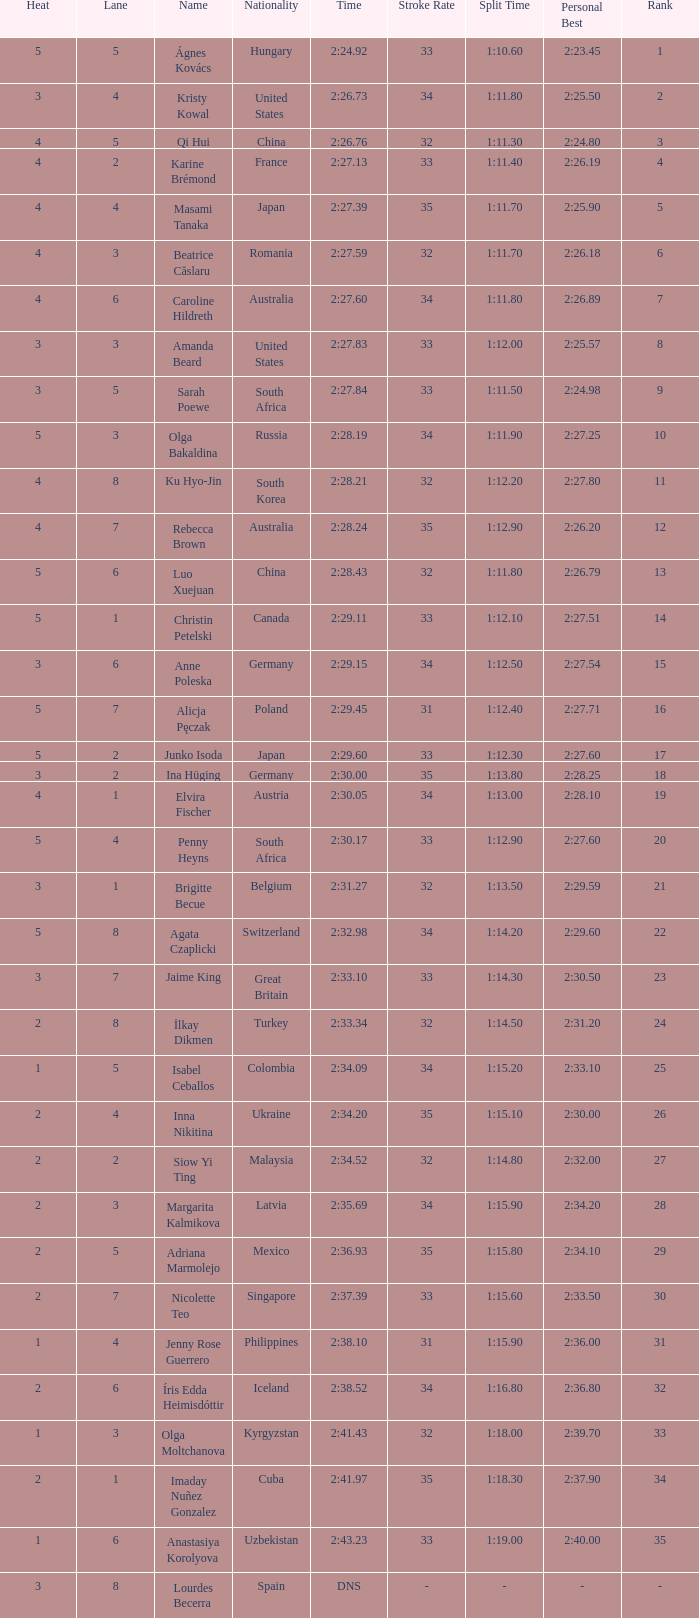What is the name that saw 4 heats and a lane higher than 7? Ku Hyo-Jin. 